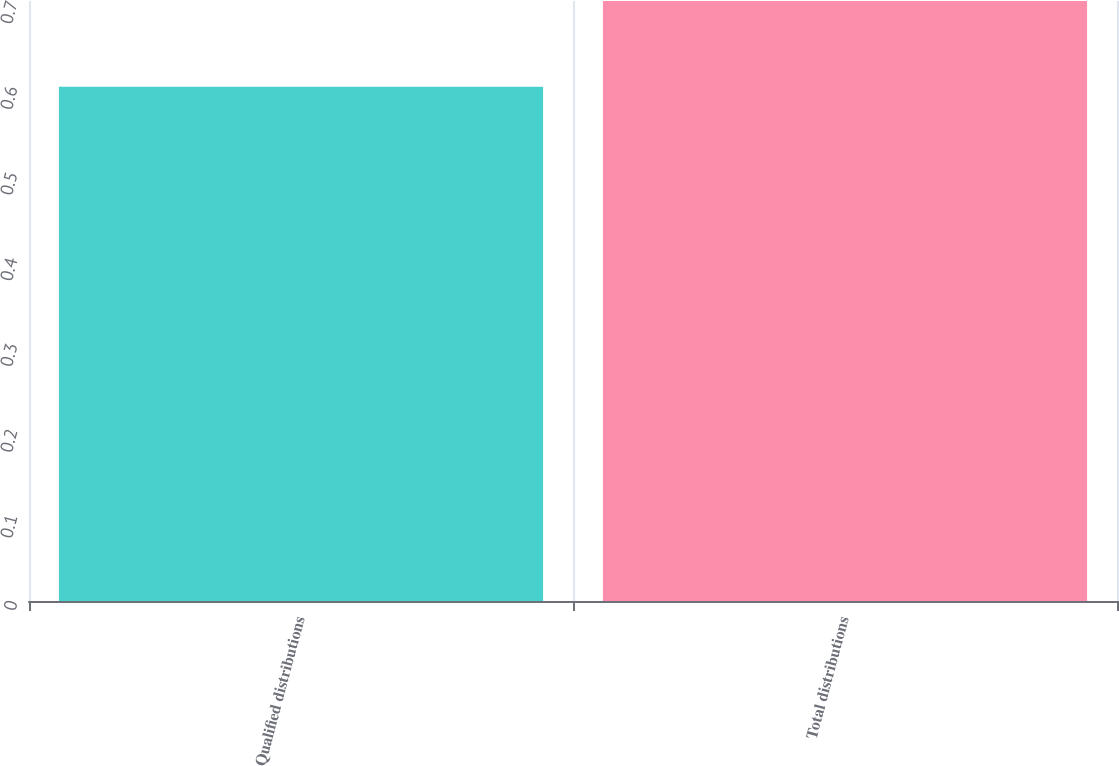<chart> <loc_0><loc_0><loc_500><loc_500><bar_chart><fcel>Qualified distributions<fcel>Total distributions<nl><fcel>0.6<fcel>0.7<nl></chart> 